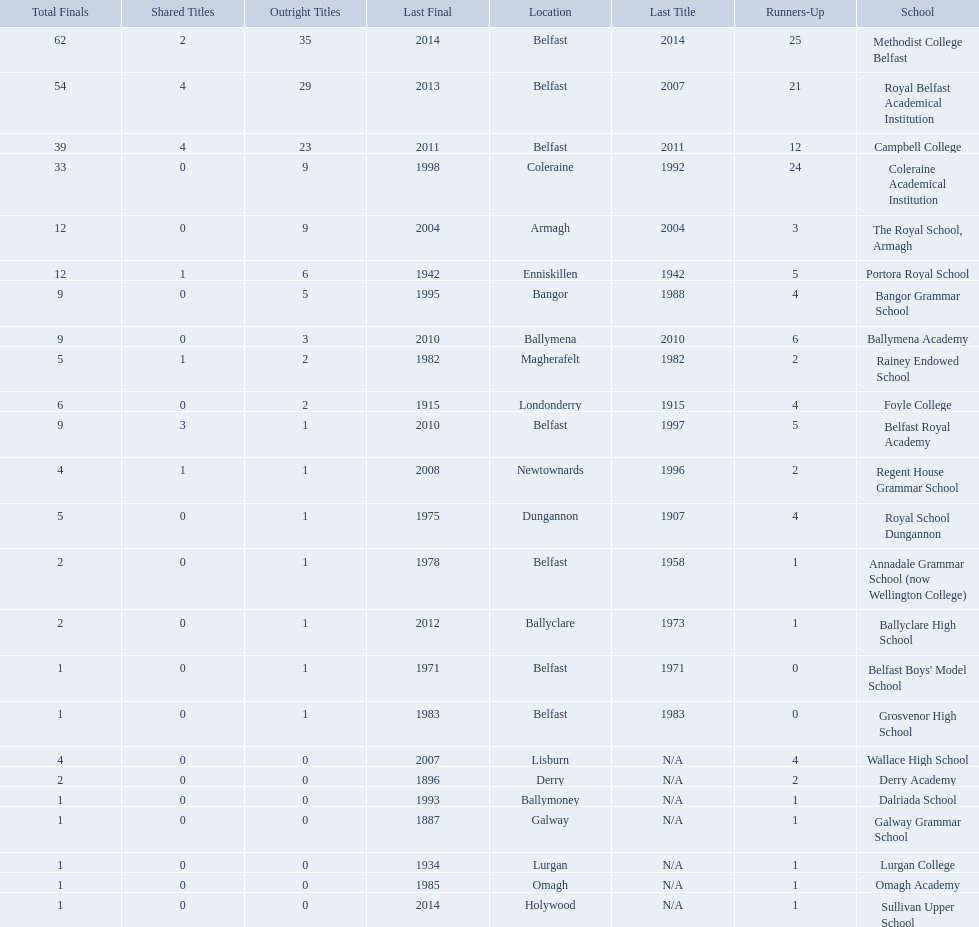How many outright titles does coleraine academical institution have? 9. What other school has this amount of outright titles The Royal School, Armagh. 